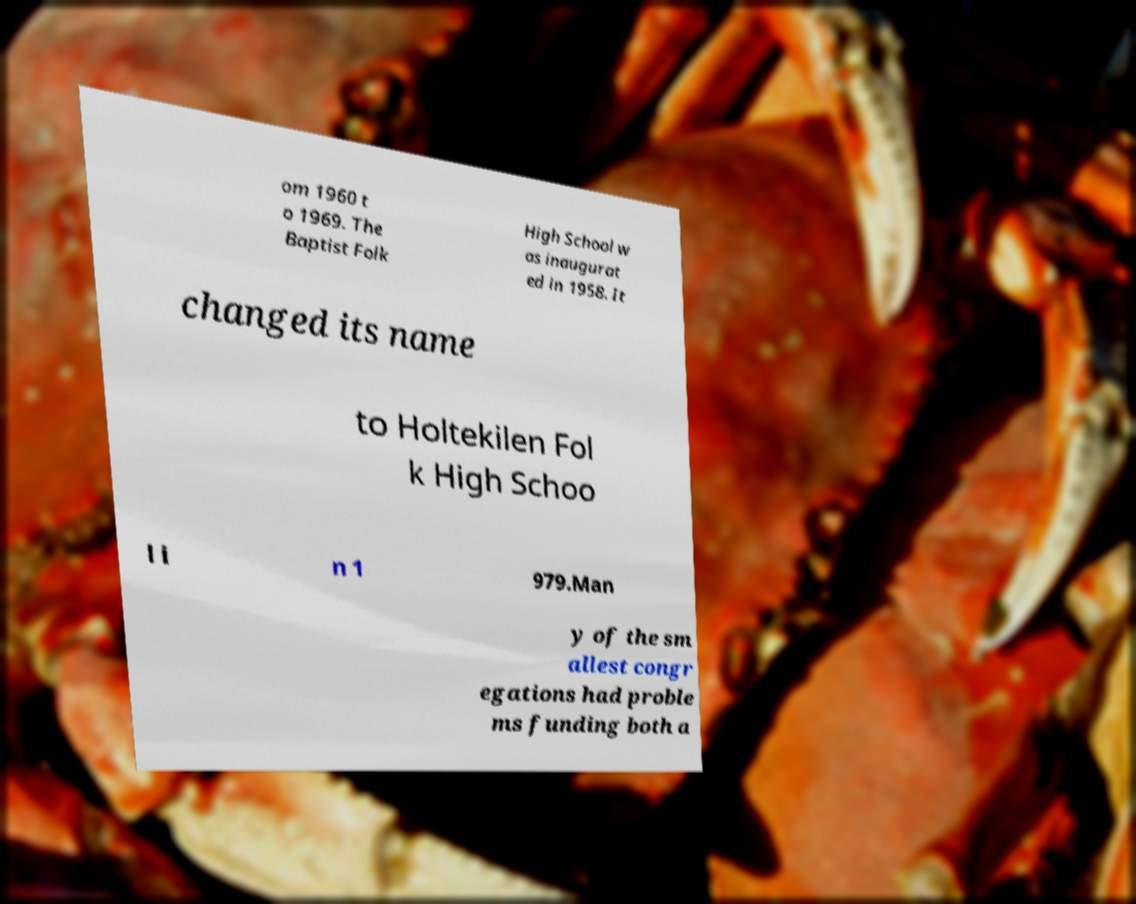Can you accurately transcribe the text from the provided image for me? om 1960 t o 1969. The Baptist Folk High School w as inaugurat ed in 1958. It changed its name to Holtekilen Fol k High Schoo l i n 1 979.Man y of the sm allest congr egations had proble ms funding both a 